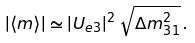<formula> <loc_0><loc_0><loc_500><loc_500>| \langle { m } \rangle | \simeq | U _ { e 3 } | ^ { 2 } \, \sqrt { \Delta { m } ^ { 2 } _ { 3 1 } } \, .</formula> 